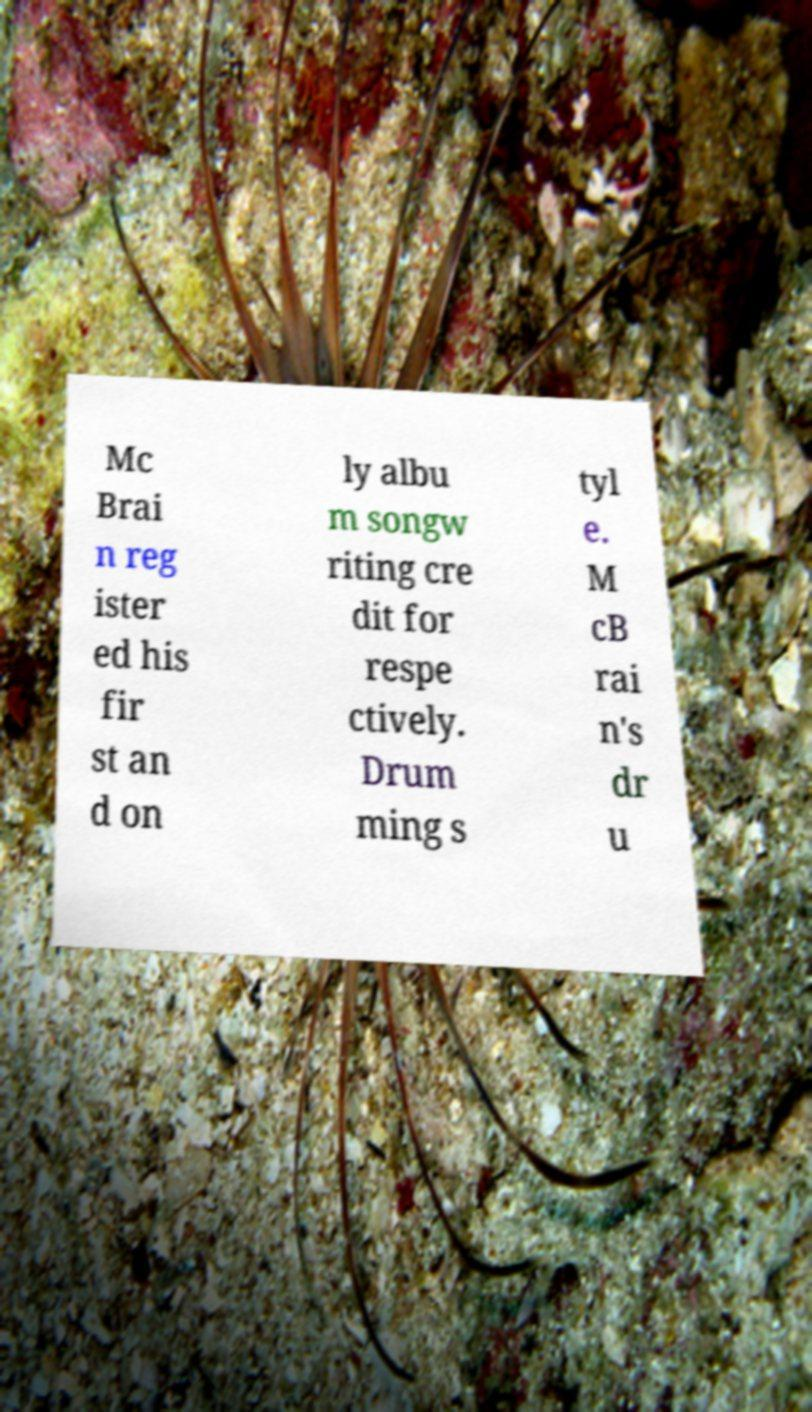For documentation purposes, I need the text within this image transcribed. Could you provide that? Mc Brai n reg ister ed his fir st an d on ly albu m songw riting cre dit for respe ctively. Drum ming s tyl e. M cB rai n's dr u 